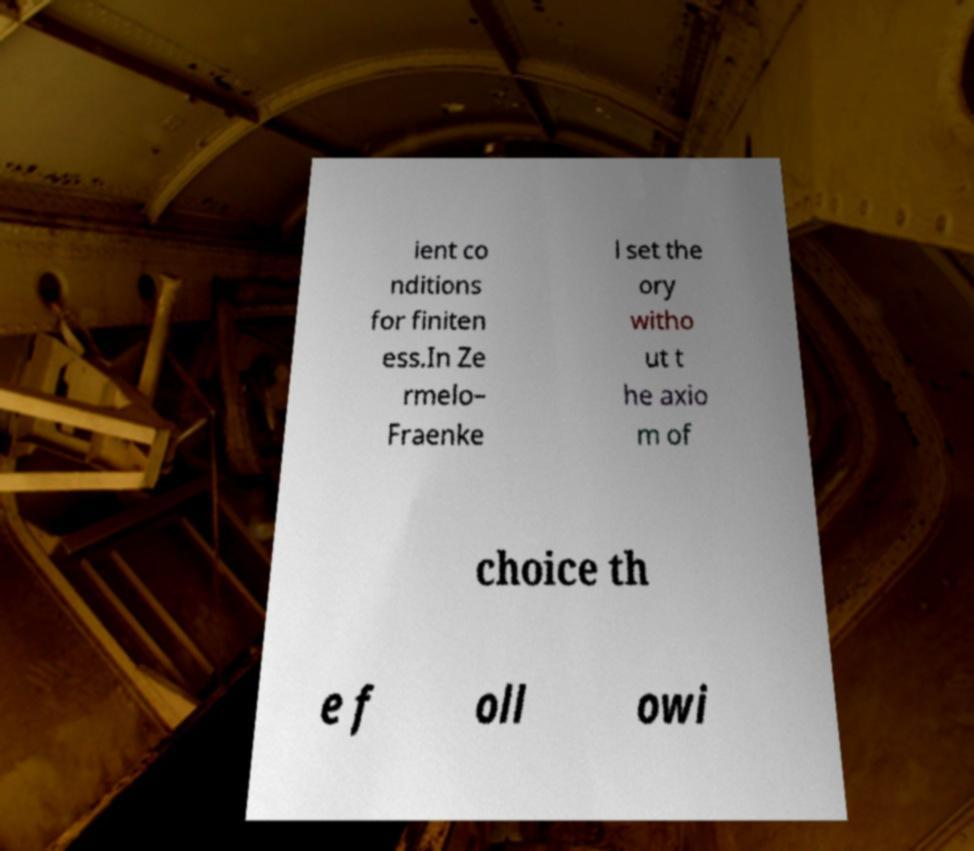Could you extract and type out the text from this image? ient co nditions for finiten ess.In Ze rmelo– Fraenke l set the ory witho ut t he axio m of choice th e f oll owi 